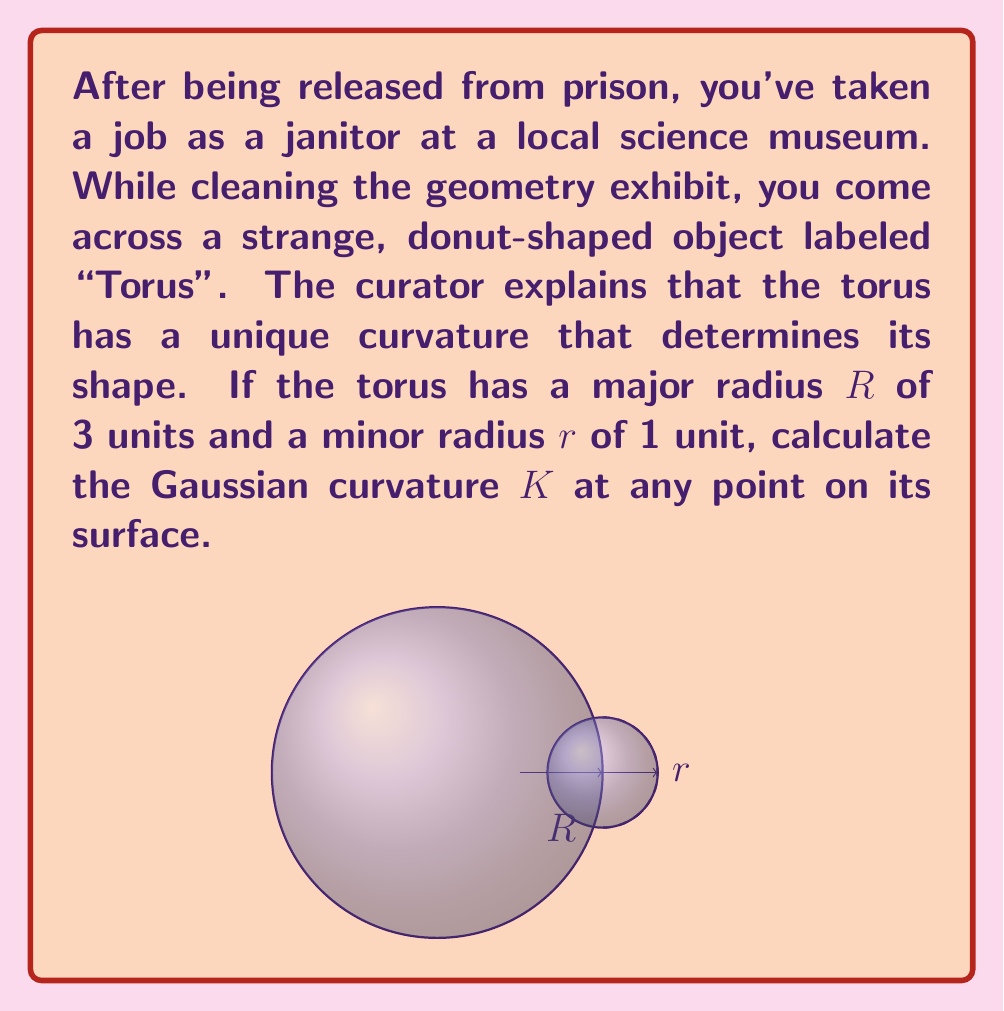Help me with this question. To solve this problem, we'll follow these steps:

1) The Gaussian curvature $K$ of a torus at any point is given by the formula:

   $$K = \frac{\cos \phi}{r(R + r\cos \phi)}$$

   where $\phi$ is the angle that parameterizes the minor circle, $R$ is the major radius, and $r$ is the minor radius.

2) We're asked to find the curvature at any point, which means we need to eliminate the $\phi$ dependence.

3) The Gaussian curvature of a torus is always positive on the outer part (where $\cos \phi > 0$) and negative on the inner part (where $\cos \phi < 0$).

4) The maximum positive curvature occurs at $\phi = 0$ (outermost part), and the maximum negative curvature occurs at $\phi = \pi$ (innermost part).

5) We can find these extreme values:

   Maximum positive curvature: $$K_{max} = \frac{1}{r(R + r)} = \frac{1}{1(3 + 1)} = \frac{1}{4} = 0.25$$

   Maximum negative curvature: $$K_{min} = \frac{-1}{r(R - r)} = \frac{-1}{1(3 - 1)} = -\frac{1}{2} = -0.5$$

6) Therefore, the Gaussian curvature at any point on the torus varies between -0.5 and 0.25.
Answer: $-0.5 \leq K \leq 0.25$ 